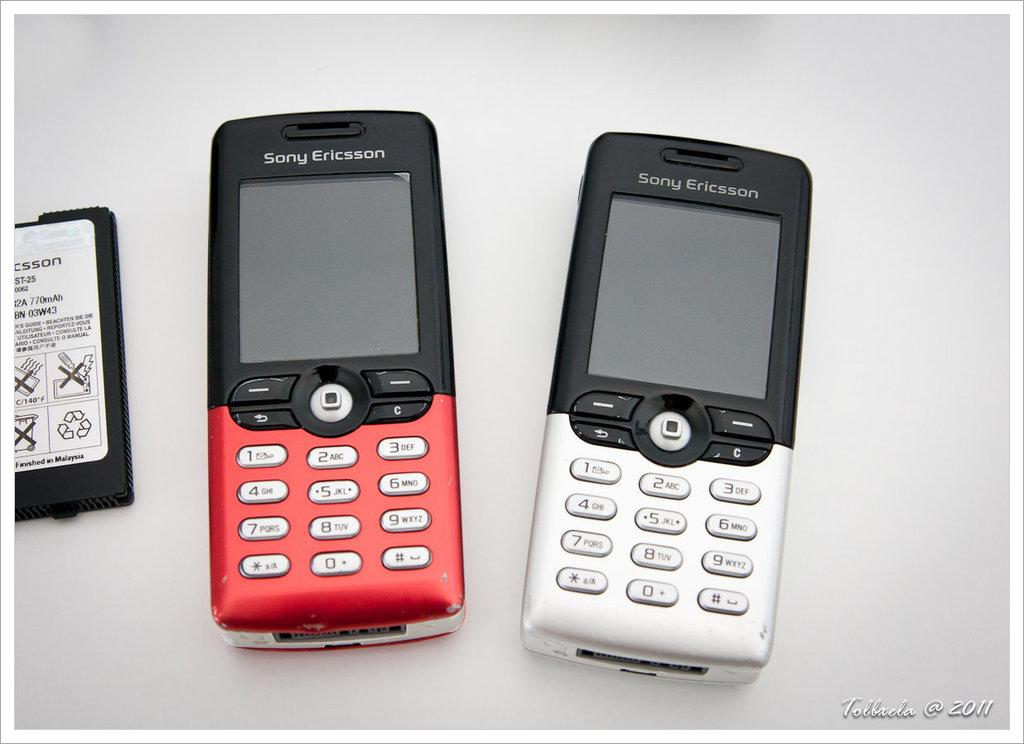What type of object is in the image? There is a battery in the image. What electronic devices are present in the image? There are two mobile phones in the image. Where are the mobile phones located in relation to the battery? The mobile phones are placed beside the battery. What type of invention is being showcased during the voyage in the image? There is no voyage or invention present in the image; it features a battery and two mobile phones. 